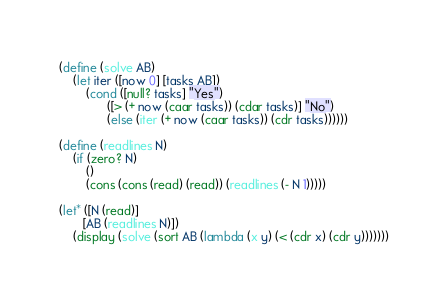<code> <loc_0><loc_0><loc_500><loc_500><_Scheme_>(define (solve AB)
    (let iter ([now 0] [tasks AB])
        (cond ([null? tasks] "Yes")
              ([> (+ now (caar tasks)) (cdar tasks)] "No")
              (else (iter (+ now (caar tasks)) (cdr tasks))))))

(define (readlines N)
    (if (zero? N)
        ()
        (cons (cons (read) (read)) (readlines (- N 1)))))

(let* ([N (read)]
       [AB (readlines N)])
    (display (solve (sort AB (lambda (x y) (< (cdr x) (cdr y)))))))</code> 